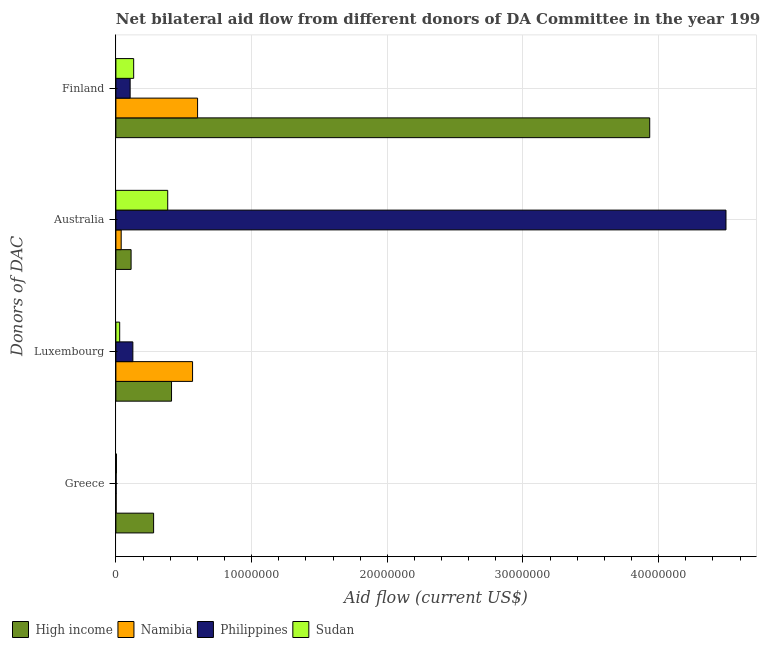How many different coloured bars are there?
Ensure brevity in your answer.  4. How many groups of bars are there?
Provide a short and direct response. 4. What is the amount of aid given by greece in High income?
Provide a succinct answer. 2.78e+06. Across all countries, what is the maximum amount of aid given by australia?
Your answer should be very brief. 4.50e+07. Across all countries, what is the minimum amount of aid given by finland?
Offer a terse response. 1.05e+06. In which country was the amount of aid given by australia maximum?
Your response must be concise. Philippines. In which country was the amount of aid given by luxembourg minimum?
Your answer should be compact. Sudan. What is the total amount of aid given by luxembourg in the graph?
Your answer should be very brief. 1.13e+07. What is the difference between the amount of aid given by australia in Sudan and that in High income?
Give a very brief answer. 2.70e+06. What is the difference between the amount of aid given by luxembourg in Philippines and the amount of aid given by greece in High income?
Ensure brevity in your answer.  -1.53e+06. What is the average amount of aid given by greece per country?
Provide a short and direct response. 7.15e+05. What is the difference between the amount of aid given by finland and amount of aid given by luxembourg in Namibia?
Give a very brief answer. 3.70e+05. What is the ratio of the amount of aid given by luxembourg in Namibia to that in Philippines?
Your answer should be very brief. 4.52. What is the difference between the highest and the second highest amount of aid given by australia?
Provide a short and direct response. 4.11e+07. What is the difference between the highest and the lowest amount of aid given by finland?
Give a very brief answer. 3.83e+07. In how many countries, is the amount of aid given by luxembourg greater than the average amount of aid given by luxembourg taken over all countries?
Provide a succinct answer. 2. Is it the case that in every country, the sum of the amount of aid given by luxembourg and amount of aid given by finland is greater than the sum of amount of aid given by greece and amount of aid given by australia?
Make the answer very short. No. What does the 2nd bar from the top in Australia represents?
Give a very brief answer. Philippines. Is it the case that in every country, the sum of the amount of aid given by greece and amount of aid given by luxembourg is greater than the amount of aid given by australia?
Your answer should be compact. No. What is the difference between two consecutive major ticks on the X-axis?
Your response must be concise. 1.00e+07. Are the values on the major ticks of X-axis written in scientific E-notation?
Keep it short and to the point. No. Does the graph contain any zero values?
Ensure brevity in your answer.  No. Where does the legend appear in the graph?
Provide a short and direct response. Bottom left. How many legend labels are there?
Give a very brief answer. 4. What is the title of the graph?
Your response must be concise. Net bilateral aid flow from different donors of DA Committee in the year 1998. What is the label or title of the X-axis?
Offer a very short reply. Aid flow (current US$). What is the label or title of the Y-axis?
Offer a terse response. Donors of DAC. What is the Aid flow (current US$) of High income in Greece?
Offer a very short reply. 2.78e+06. What is the Aid flow (current US$) in Namibia in Greece?
Offer a very short reply. 2.00e+04. What is the Aid flow (current US$) of Sudan in Greece?
Make the answer very short. 4.00e+04. What is the Aid flow (current US$) in High income in Luxembourg?
Your answer should be compact. 4.10e+06. What is the Aid flow (current US$) in Namibia in Luxembourg?
Make the answer very short. 5.65e+06. What is the Aid flow (current US$) of Philippines in Luxembourg?
Offer a terse response. 1.25e+06. What is the Aid flow (current US$) in Sudan in Luxembourg?
Provide a succinct answer. 2.80e+05. What is the Aid flow (current US$) in High income in Australia?
Ensure brevity in your answer.  1.12e+06. What is the Aid flow (current US$) of Namibia in Australia?
Your answer should be very brief. 3.90e+05. What is the Aid flow (current US$) of Philippines in Australia?
Offer a very short reply. 4.50e+07. What is the Aid flow (current US$) in Sudan in Australia?
Provide a succinct answer. 3.82e+06. What is the Aid flow (current US$) in High income in Finland?
Offer a terse response. 3.93e+07. What is the Aid flow (current US$) in Namibia in Finland?
Provide a succinct answer. 6.02e+06. What is the Aid flow (current US$) in Philippines in Finland?
Make the answer very short. 1.05e+06. What is the Aid flow (current US$) in Sudan in Finland?
Provide a short and direct response. 1.31e+06. Across all Donors of DAC, what is the maximum Aid flow (current US$) of High income?
Your answer should be very brief. 3.93e+07. Across all Donors of DAC, what is the maximum Aid flow (current US$) in Namibia?
Your answer should be very brief. 6.02e+06. Across all Donors of DAC, what is the maximum Aid flow (current US$) in Philippines?
Offer a terse response. 4.50e+07. Across all Donors of DAC, what is the maximum Aid flow (current US$) of Sudan?
Ensure brevity in your answer.  3.82e+06. Across all Donors of DAC, what is the minimum Aid flow (current US$) in High income?
Offer a terse response. 1.12e+06. Across all Donors of DAC, what is the minimum Aid flow (current US$) in Namibia?
Offer a terse response. 2.00e+04. Across all Donors of DAC, what is the minimum Aid flow (current US$) in Sudan?
Make the answer very short. 4.00e+04. What is the total Aid flow (current US$) of High income in the graph?
Ensure brevity in your answer.  4.73e+07. What is the total Aid flow (current US$) in Namibia in the graph?
Keep it short and to the point. 1.21e+07. What is the total Aid flow (current US$) in Philippines in the graph?
Keep it short and to the point. 4.73e+07. What is the total Aid flow (current US$) in Sudan in the graph?
Your answer should be compact. 5.45e+06. What is the difference between the Aid flow (current US$) in High income in Greece and that in Luxembourg?
Your response must be concise. -1.32e+06. What is the difference between the Aid flow (current US$) in Namibia in Greece and that in Luxembourg?
Ensure brevity in your answer.  -5.63e+06. What is the difference between the Aid flow (current US$) of Philippines in Greece and that in Luxembourg?
Provide a short and direct response. -1.23e+06. What is the difference between the Aid flow (current US$) in High income in Greece and that in Australia?
Give a very brief answer. 1.66e+06. What is the difference between the Aid flow (current US$) of Namibia in Greece and that in Australia?
Provide a succinct answer. -3.70e+05. What is the difference between the Aid flow (current US$) in Philippines in Greece and that in Australia?
Make the answer very short. -4.49e+07. What is the difference between the Aid flow (current US$) of Sudan in Greece and that in Australia?
Offer a terse response. -3.78e+06. What is the difference between the Aid flow (current US$) of High income in Greece and that in Finland?
Offer a very short reply. -3.66e+07. What is the difference between the Aid flow (current US$) in Namibia in Greece and that in Finland?
Offer a terse response. -6.00e+06. What is the difference between the Aid flow (current US$) of Philippines in Greece and that in Finland?
Offer a very short reply. -1.03e+06. What is the difference between the Aid flow (current US$) in Sudan in Greece and that in Finland?
Offer a very short reply. -1.27e+06. What is the difference between the Aid flow (current US$) in High income in Luxembourg and that in Australia?
Provide a short and direct response. 2.98e+06. What is the difference between the Aid flow (current US$) in Namibia in Luxembourg and that in Australia?
Your answer should be very brief. 5.26e+06. What is the difference between the Aid flow (current US$) in Philippines in Luxembourg and that in Australia?
Provide a succinct answer. -4.37e+07. What is the difference between the Aid flow (current US$) in Sudan in Luxembourg and that in Australia?
Offer a very short reply. -3.54e+06. What is the difference between the Aid flow (current US$) of High income in Luxembourg and that in Finland?
Your answer should be compact. -3.52e+07. What is the difference between the Aid flow (current US$) of Namibia in Luxembourg and that in Finland?
Ensure brevity in your answer.  -3.70e+05. What is the difference between the Aid flow (current US$) in Philippines in Luxembourg and that in Finland?
Your answer should be very brief. 2.00e+05. What is the difference between the Aid flow (current US$) in Sudan in Luxembourg and that in Finland?
Keep it short and to the point. -1.03e+06. What is the difference between the Aid flow (current US$) of High income in Australia and that in Finland?
Make the answer very short. -3.82e+07. What is the difference between the Aid flow (current US$) of Namibia in Australia and that in Finland?
Offer a terse response. -5.63e+06. What is the difference between the Aid flow (current US$) of Philippines in Australia and that in Finland?
Keep it short and to the point. 4.39e+07. What is the difference between the Aid flow (current US$) in Sudan in Australia and that in Finland?
Your answer should be very brief. 2.51e+06. What is the difference between the Aid flow (current US$) in High income in Greece and the Aid flow (current US$) in Namibia in Luxembourg?
Make the answer very short. -2.87e+06. What is the difference between the Aid flow (current US$) in High income in Greece and the Aid flow (current US$) in Philippines in Luxembourg?
Your response must be concise. 1.53e+06. What is the difference between the Aid flow (current US$) of High income in Greece and the Aid flow (current US$) of Sudan in Luxembourg?
Make the answer very short. 2.50e+06. What is the difference between the Aid flow (current US$) in Namibia in Greece and the Aid flow (current US$) in Philippines in Luxembourg?
Your answer should be compact. -1.23e+06. What is the difference between the Aid flow (current US$) in Namibia in Greece and the Aid flow (current US$) in Sudan in Luxembourg?
Make the answer very short. -2.60e+05. What is the difference between the Aid flow (current US$) of High income in Greece and the Aid flow (current US$) of Namibia in Australia?
Your response must be concise. 2.39e+06. What is the difference between the Aid flow (current US$) in High income in Greece and the Aid flow (current US$) in Philippines in Australia?
Your response must be concise. -4.22e+07. What is the difference between the Aid flow (current US$) of High income in Greece and the Aid flow (current US$) of Sudan in Australia?
Your response must be concise. -1.04e+06. What is the difference between the Aid flow (current US$) of Namibia in Greece and the Aid flow (current US$) of Philippines in Australia?
Keep it short and to the point. -4.49e+07. What is the difference between the Aid flow (current US$) in Namibia in Greece and the Aid flow (current US$) in Sudan in Australia?
Ensure brevity in your answer.  -3.80e+06. What is the difference between the Aid flow (current US$) in Philippines in Greece and the Aid flow (current US$) in Sudan in Australia?
Provide a short and direct response. -3.80e+06. What is the difference between the Aid flow (current US$) of High income in Greece and the Aid flow (current US$) of Namibia in Finland?
Offer a terse response. -3.24e+06. What is the difference between the Aid flow (current US$) in High income in Greece and the Aid flow (current US$) in Philippines in Finland?
Your answer should be compact. 1.73e+06. What is the difference between the Aid flow (current US$) in High income in Greece and the Aid flow (current US$) in Sudan in Finland?
Your answer should be very brief. 1.47e+06. What is the difference between the Aid flow (current US$) of Namibia in Greece and the Aid flow (current US$) of Philippines in Finland?
Give a very brief answer. -1.03e+06. What is the difference between the Aid flow (current US$) in Namibia in Greece and the Aid flow (current US$) in Sudan in Finland?
Offer a terse response. -1.29e+06. What is the difference between the Aid flow (current US$) in Philippines in Greece and the Aid flow (current US$) in Sudan in Finland?
Give a very brief answer. -1.29e+06. What is the difference between the Aid flow (current US$) in High income in Luxembourg and the Aid flow (current US$) in Namibia in Australia?
Offer a very short reply. 3.71e+06. What is the difference between the Aid flow (current US$) in High income in Luxembourg and the Aid flow (current US$) in Philippines in Australia?
Offer a terse response. -4.09e+07. What is the difference between the Aid flow (current US$) of Namibia in Luxembourg and the Aid flow (current US$) of Philippines in Australia?
Your answer should be compact. -3.93e+07. What is the difference between the Aid flow (current US$) in Namibia in Luxembourg and the Aid flow (current US$) in Sudan in Australia?
Ensure brevity in your answer.  1.83e+06. What is the difference between the Aid flow (current US$) of Philippines in Luxembourg and the Aid flow (current US$) of Sudan in Australia?
Provide a short and direct response. -2.57e+06. What is the difference between the Aid flow (current US$) of High income in Luxembourg and the Aid flow (current US$) of Namibia in Finland?
Ensure brevity in your answer.  -1.92e+06. What is the difference between the Aid flow (current US$) of High income in Luxembourg and the Aid flow (current US$) of Philippines in Finland?
Your response must be concise. 3.05e+06. What is the difference between the Aid flow (current US$) of High income in Luxembourg and the Aid flow (current US$) of Sudan in Finland?
Offer a terse response. 2.79e+06. What is the difference between the Aid flow (current US$) in Namibia in Luxembourg and the Aid flow (current US$) in Philippines in Finland?
Keep it short and to the point. 4.60e+06. What is the difference between the Aid flow (current US$) of Namibia in Luxembourg and the Aid flow (current US$) of Sudan in Finland?
Your answer should be compact. 4.34e+06. What is the difference between the Aid flow (current US$) of High income in Australia and the Aid flow (current US$) of Namibia in Finland?
Offer a very short reply. -4.90e+06. What is the difference between the Aid flow (current US$) in High income in Australia and the Aid flow (current US$) in Sudan in Finland?
Your answer should be very brief. -1.90e+05. What is the difference between the Aid flow (current US$) of Namibia in Australia and the Aid flow (current US$) of Philippines in Finland?
Keep it short and to the point. -6.60e+05. What is the difference between the Aid flow (current US$) of Namibia in Australia and the Aid flow (current US$) of Sudan in Finland?
Give a very brief answer. -9.20e+05. What is the difference between the Aid flow (current US$) in Philippines in Australia and the Aid flow (current US$) in Sudan in Finland?
Provide a short and direct response. 4.36e+07. What is the average Aid flow (current US$) of High income per Donors of DAC?
Give a very brief answer. 1.18e+07. What is the average Aid flow (current US$) of Namibia per Donors of DAC?
Your answer should be very brief. 3.02e+06. What is the average Aid flow (current US$) in Philippines per Donors of DAC?
Make the answer very short. 1.18e+07. What is the average Aid flow (current US$) in Sudan per Donors of DAC?
Ensure brevity in your answer.  1.36e+06. What is the difference between the Aid flow (current US$) of High income and Aid flow (current US$) of Namibia in Greece?
Your answer should be compact. 2.76e+06. What is the difference between the Aid flow (current US$) in High income and Aid flow (current US$) in Philippines in Greece?
Your answer should be very brief. 2.76e+06. What is the difference between the Aid flow (current US$) of High income and Aid flow (current US$) of Sudan in Greece?
Your answer should be very brief. 2.74e+06. What is the difference between the Aid flow (current US$) in Philippines and Aid flow (current US$) in Sudan in Greece?
Make the answer very short. -2.00e+04. What is the difference between the Aid flow (current US$) in High income and Aid flow (current US$) in Namibia in Luxembourg?
Give a very brief answer. -1.55e+06. What is the difference between the Aid flow (current US$) of High income and Aid flow (current US$) of Philippines in Luxembourg?
Provide a short and direct response. 2.85e+06. What is the difference between the Aid flow (current US$) in High income and Aid flow (current US$) in Sudan in Luxembourg?
Make the answer very short. 3.82e+06. What is the difference between the Aid flow (current US$) of Namibia and Aid flow (current US$) of Philippines in Luxembourg?
Provide a short and direct response. 4.40e+06. What is the difference between the Aid flow (current US$) of Namibia and Aid flow (current US$) of Sudan in Luxembourg?
Make the answer very short. 5.37e+06. What is the difference between the Aid flow (current US$) of Philippines and Aid flow (current US$) of Sudan in Luxembourg?
Ensure brevity in your answer.  9.70e+05. What is the difference between the Aid flow (current US$) in High income and Aid flow (current US$) in Namibia in Australia?
Offer a very short reply. 7.30e+05. What is the difference between the Aid flow (current US$) of High income and Aid flow (current US$) of Philippines in Australia?
Provide a short and direct response. -4.38e+07. What is the difference between the Aid flow (current US$) in High income and Aid flow (current US$) in Sudan in Australia?
Provide a succinct answer. -2.70e+06. What is the difference between the Aid flow (current US$) of Namibia and Aid flow (current US$) of Philippines in Australia?
Make the answer very short. -4.46e+07. What is the difference between the Aid flow (current US$) in Namibia and Aid flow (current US$) in Sudan in Australia?
Your answer should be very brief. -3.43e+06. What is the difference between the Aid flow (current US$) in Philippines and Aid flow (current US$) in Sudan in Australia?
Offer a very short reply. 4.11e+07. What is the difference between the Aid flow (current US$) of High income and Aid flow (current US$) of Namibia in Finland?
Provide a short and direct response. 3.33e+07. What is the difference between the Aid flow (current US$) of High income and Aid flow (current US$) of Philippines in Finland?
Keep it short and to the point. 3.83e+07. What is the difference between the Aid flow (current US$) in High income and Aid flow (current US$) in Sudan in Finland?
Your answer should be compact. 3.80e+07. What is the difference between the Aid flow (current US$) in Namibia and Aid flow (current US$) in Philippines in Finland?
Keep it short and to the point. 4.97e+06. What is the difference between the Aid flow (current US$) of Namibia and Aid flow (current US$) of Sudan in Finland?
Provide a short and direct response. 4.71e+06. What is the ratio of the Aid flow (current US$) of High income in Greece to that in Luxembourg?
Make the answer very short. 0.68. What is the ratio of the Aid flow (current US$) in Namibia in Greece to that in Luxembourg?
Give a very brief answer. 0. What is the ratio of the Aid flow (current US$) in Philippines in Greece to that in Luxembourg?
Give a very brief answer. 0.02. What is the ratio of the Aid flow (current US$) in Sudan in Greece to that in Luxembourg?
Provide a short and direct response. 0.14. What is the ratio of the Aid flow (current US$) of High income in Greece to that in Australia?
Your answer should be compact. 2.48. What is the ratio of the Aid flow (current US$) of Namibia in Greece to that in Australia?
Make the answer very short. 0.05. What is the ratio of the Aid flow (current US$) of Philippines in Greece to that in Australia?
Make the answer very short. 0. What is the ratio of the Aid flow (current US$) of Sudan in Greece to that in Australia?
Make the answer very short. 0.01. What is the ratio of the Aid flow (current US$) of High income in Greece to that in Finland?
Your answer should be very brief. 0.07. What is the ratio of the Aid flow (current US$) of Namibia in Greece to that in Finland?
Ensure brevity in your answer.  0. What is the ratio of the Aid flow (current US$) of Philippines in Greece to that in Finland?
Offer a very short reply. 0.02. What is the ratio of the Aid flow (current US$) of Sudan in Greece to that in Finland?
Provide a short and direct response. 0.03. What is the ratio of the Aid flow (current US$) of High income in Luxembourg to that in Australia?
Make the answer very short. 3.66. What is the ratio of the Aid flow (current US$) in Namibia in Luxembourg to that in Australia?
Keep it short and to the point. 14.49. What is the ratio of the Aid flow (current US$) in Philippines in Luxembourg to that in Australia?
Provide a succinct answer. 0.03. What is the ratio of the Aid flow (current US$) of Sudan in Luxembourg to that in Australia?
Make the answer very short. 0.07. What is the ratio of the Aid flow (current US$) in High income in Luxembourg to that in Finland?
Your answer should be compact. 0.1. What is the ratio of the Aid flow (current US$) of Namibia in Luxembourg to that in Finland?
Provide a short and direct response. 0.94. What is the ratio of the Aid flow (current US$) in Philippines in Luxembourg to that in Finland?
Make the answer very short. 1.19. What is the ratio of the Aid flow (current US$) in Sudan in Luxembourg to that in Finland?
Your response must be concise. 0.21. What is the ratio of the Aid flow (current US$) in High income in Australia to that in Finland?
Give a very brief answer. 0.03. What is the ratio of the Aid flow (current US$) in Namibia in Australia to that in Finland?
Offer a terse response. 0.06. What is the ratio of the Aid flow (current US$) in Philippines in Australia to that in Finland?
Keep it short and to the point. 42.82. What is the ratio of the Aid flow (current US$) of Sudan in Australia to that in Finland?
Make the answer very short. 2.92. What is the difference between the highest and the second highest Aid flow (current US$) in High income?
Offer a very short reply. 3.52e+07. What is the difference between the highest and the second highest Aid flow (current US$) in Philippines?
Offer a terse response. 4.37e+07. What is the difference between the highest and the second highest Aid flow (current US$) in Sudan?
Your response must be concise. 2.51e+06. What is the difference between the highest and the lowest Aid flow (current US$) of High income?
Offer a terse response. 3.82e+07. What is the difference between the highest and the lowest Aid flow (current US$) of Philippines?
Keep it short and to the point. 4.49e+07. What is the difference between the highest and the lowest Aid flow (current US$) in Sudan?
Make the answer very short. 3.78e+06. 